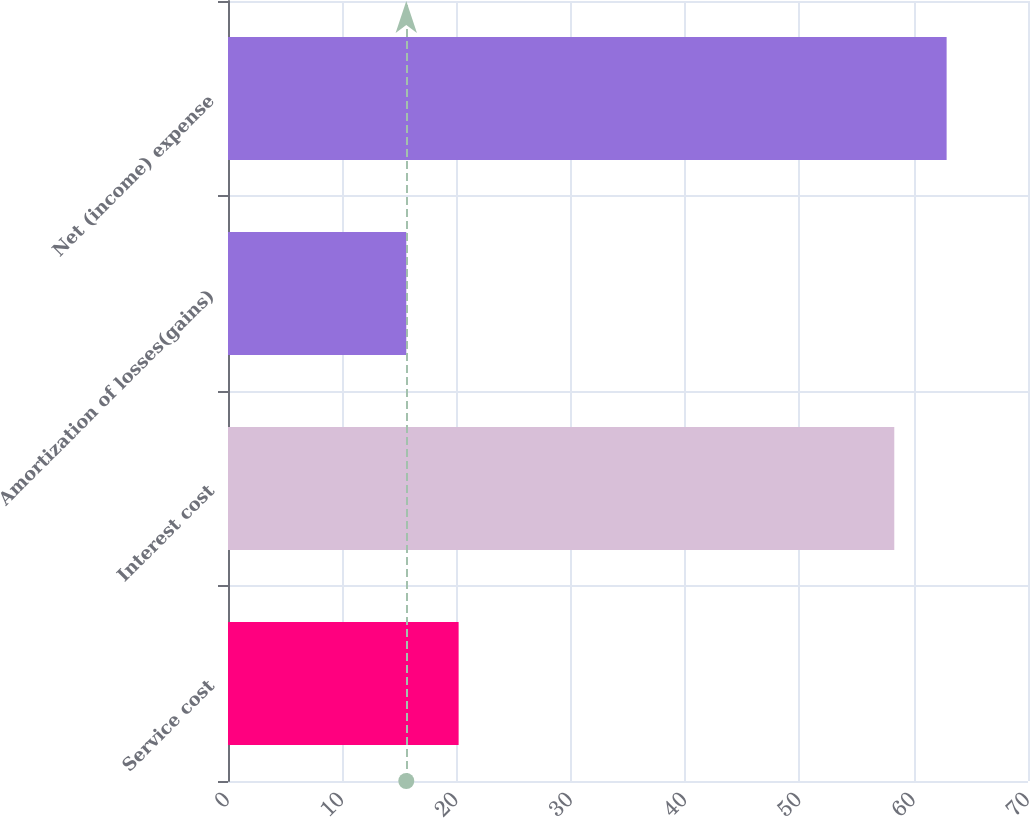<chart> <loc_0><loc_0><loc_500><loc_500><bar_chart><fcel>Service cost<fcel>Interest cost<fcel>Amortization of losses(gains)<fcel>Net (income) expense<nl><fcel>20.18<fcel>58.3<fcel>15.6<fcel>62.88<nl></chart> 